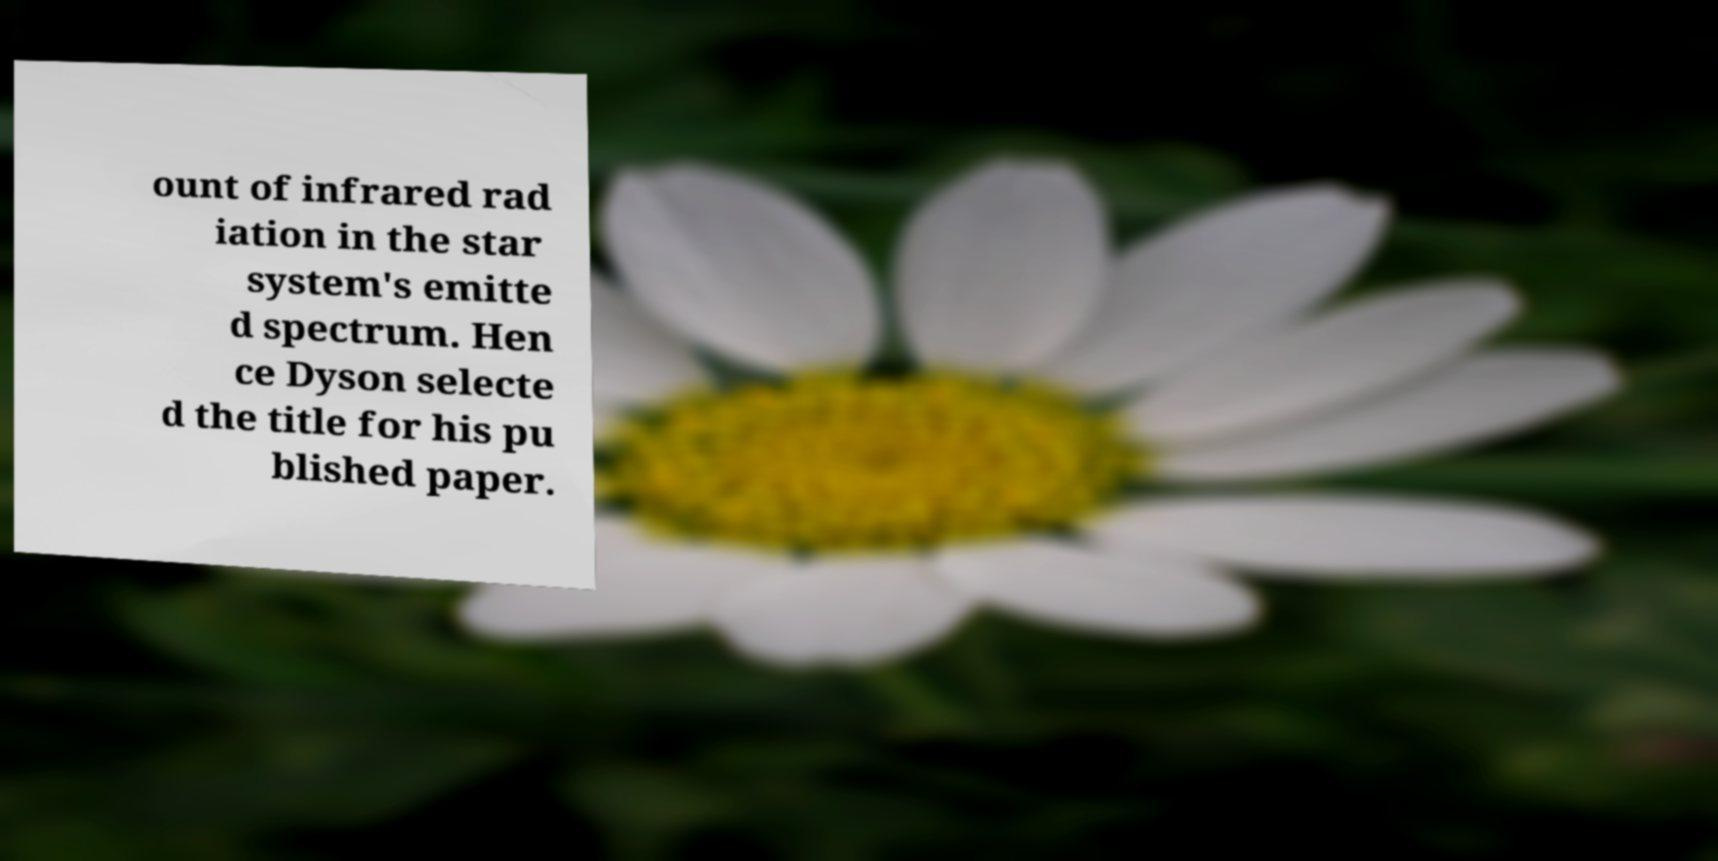Could you extract and type out the text from this image? ount of infrared rad iation in the star system's emitte d spectrum. Hen ce Dyson selecte d the title for his pu blished paper. 